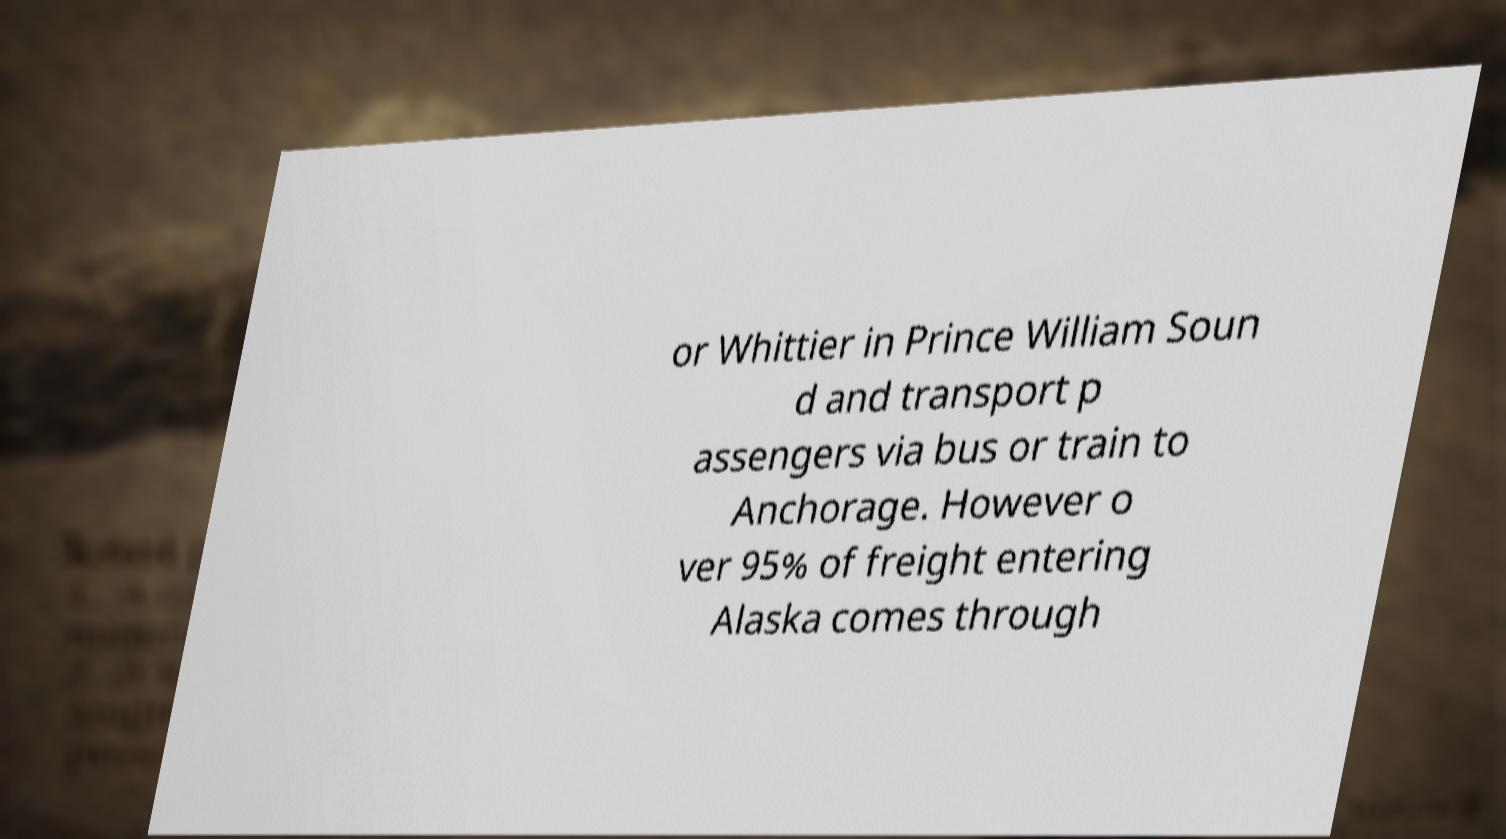There's text embedded in this image that I need extracted. Can you transcribe it verbatim? or Whittier in Prince William Soun d and transport p assengers via bus or train to Anchorage. However o ver 95% of freight entering Alaska comes through 